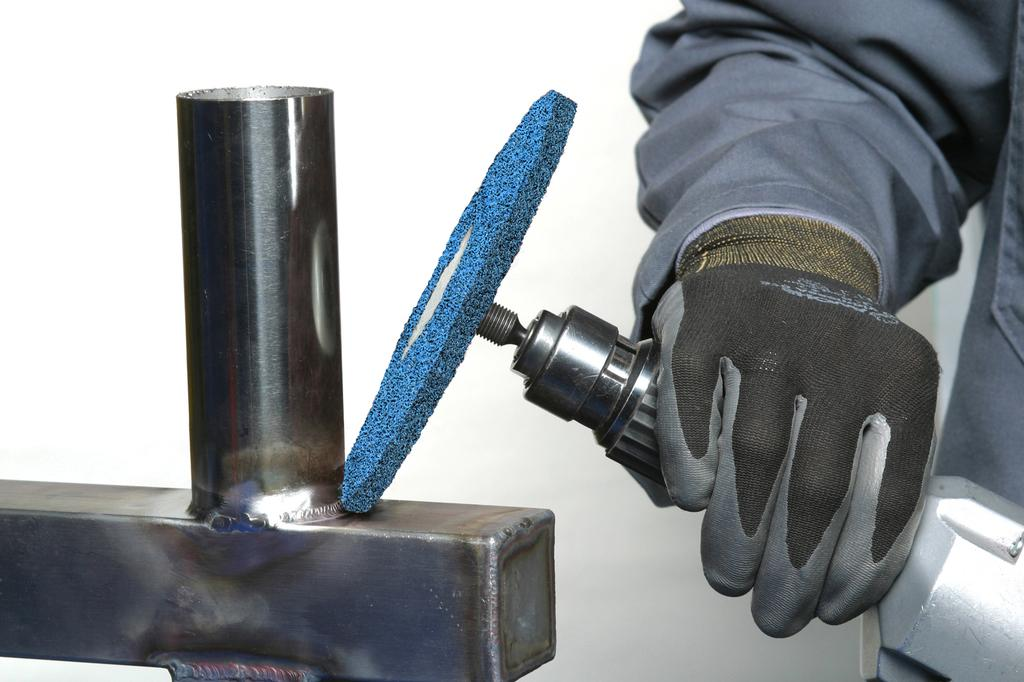What is the main subject of the image? There is a person in the image. What is the person doing in the image? The person is holding an object. Can you describe any other objects in the image? There is an iron rod on the left side of the image. What can be seen in the background of the image? There is a wall in the background of the image. What type of pain is the person experiencing in the image? There is no indication of pain in the image; the person is simply holding an object. What kind of bait is being used by the person in the image? There is no bait present in the image; the person is holding an unspecified object. 